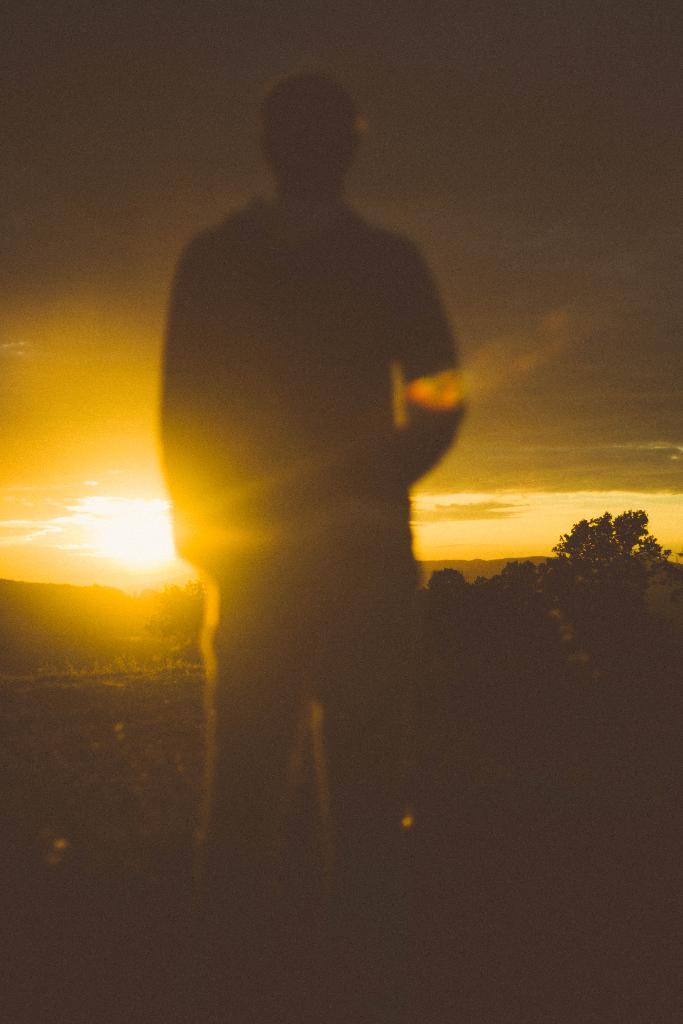What is the main subject in the front of the image? There is a man standing in the front of the image. What can be seen in the background of the image? There are trees in the background of the image. What is visible in the sky at the top of the image? The sun is visible in the sky at the top of the image. What part of the natural environment is visible in the image? The sky is visible in the image. What is the price of the slave in the image? There is no mention of a slave or any pricing information in the image. The image features a man standing in front of trees with the sun visible in the sky. 